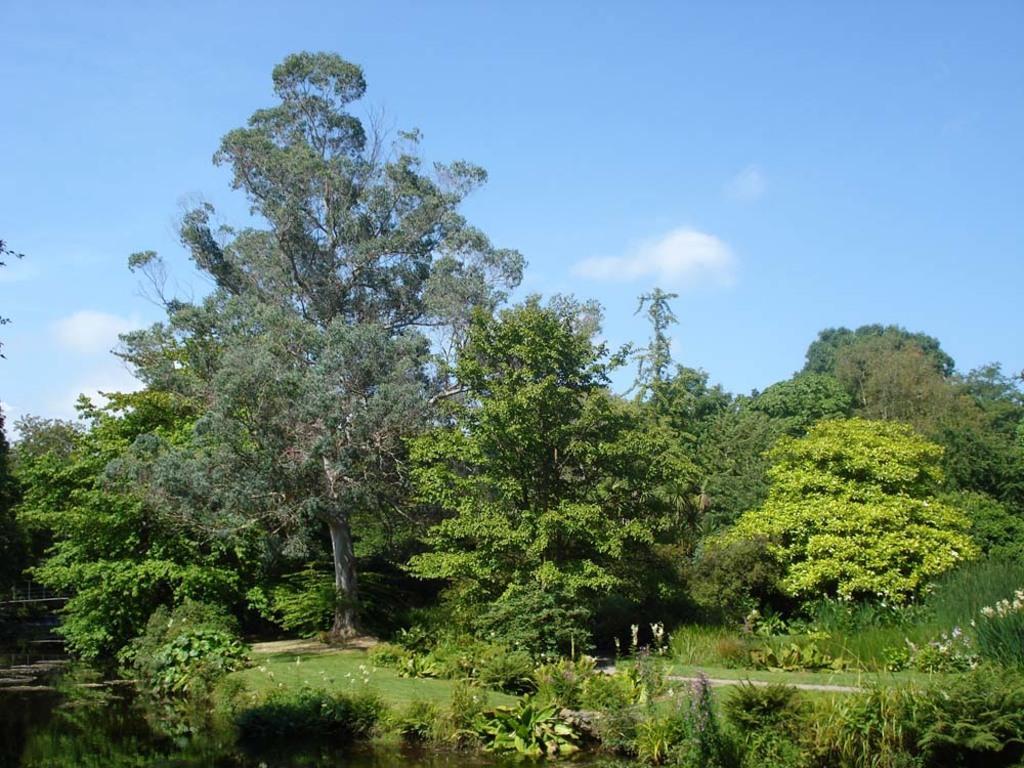In one or two sentences, can you explain what this image depicts? This image consists of trees in the middle. There is sky at the top. There are bushes at the bottom. There is water in the bottom left corner. 